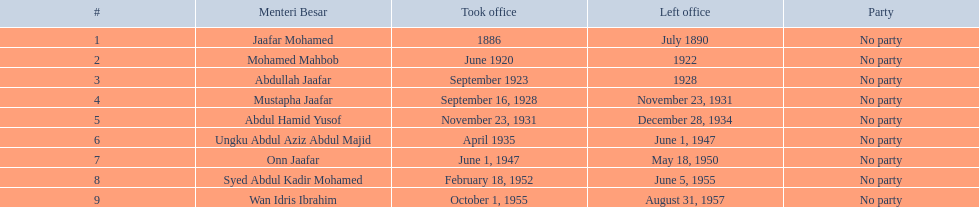Who were all the persons that occupied the role of menteri besar in johor? Jaafar Mohamed, Mohamed Mahbob, Abdullah Jaafar, Mustapha Jaafar, Abdul Hamid Yusof, Ungku Abdul Aziz Abdul Majid, Onn Jaafar, Syed Abdul Kadir Mohamed, Wan Idris Ibrahim. Who had the lengthiest rule? Ungku Abdul Aziz Abdul Majid. 